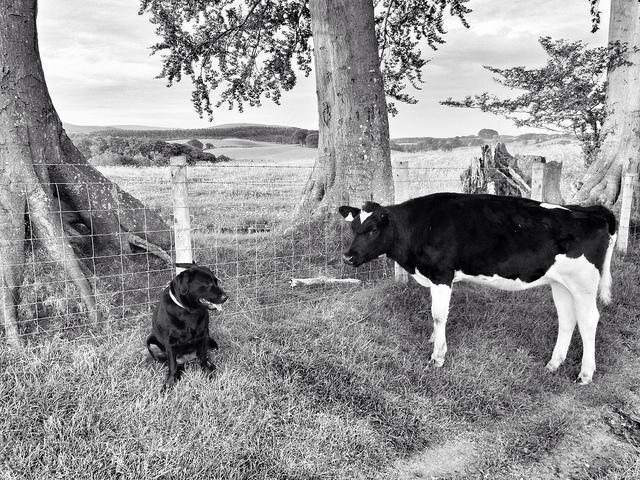How many animals are in this picture?
Give a very brief answer. 2. How many of these people are female?
Give a very brief answer. 0. 